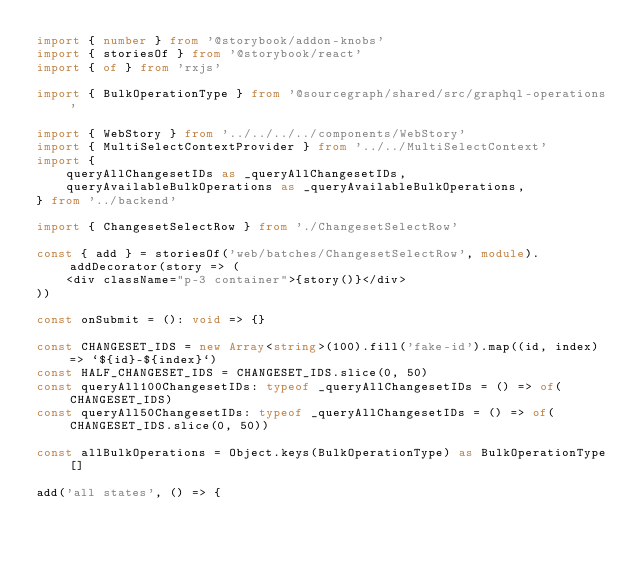<code> <loc_0><loc_0><loc_500><loc_500><_TypeScript_>import { number } from '@storybook/addon-knobs'
import { storiesOf } from '@storybook/react'
import { of } from 'rxjs'

import { BulkOperationType } from '@sourcegraph/shared/src/graphql-operations'

import { WebStory } from '../../../../components/WebStory'
import { MultiSelectContextProvider } from '../../MultiSelectContext'
import {
    queryAllChangesetIDs as _queryAllChangesetIDs,
    queryAvailableBulkOperations as _queryAvailableBulkOperations,
} from '../backend'

import { ChangesetSelectRow } from './ChangesetSelectRow'

const { add } = storiesOf('web/batches/ChangesetSelectRow', module).addDecorator(story => (
    <div className="p-3 container">{story()}</div>
))

const onSubmit = (): void => {}

const CHANGESET_IDS = new Array<string>(100).fill('fake-id').map((id, index) => `${id}-${index}`)
const HALF_CHANGESET_IDS = CHANGESET_IDS.slice(0, 50)
const queryAll100ChangesetIDs: typeof _queryAllChangesetIDs = () => of(CHANGESET_IDS)
const queryAll50ChangesetIDs: typeof _queryAllChangesetIDs = () => of(CHANGESET_IDS.slice(0, 50))

const allBulkOperations = Object.keys(BulkOperationType) as BulkOperationType[]

add('all states', () => {</code> 